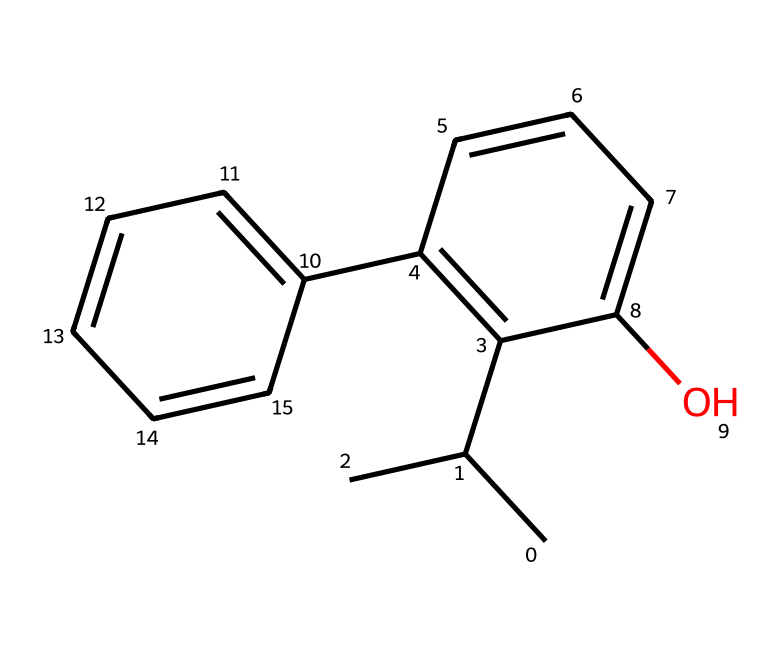What is the molecular formula of propofol? The molecular formula can be derived from the count of each type of atom present in the SMILES representation. In the given SMILES, there are 12 carbons (C), 18 hydrogens (H), and 1 oxygen (O), leading to the formula C12H18O.
Answer: C12H18O How many rings are present in the chemical structure of propofol? Analyzing the SMILES, there are two distinct cycles present: one is a six-membered cyclohexene ring and the other is a five-membered ring, which indicates that the structure contains two rings.
Answer: 2 What type of functional group is represented in propofol? The presence of -OH in the structure indicates that propofol contains a hydroxyl functional group, which is characteristic of alcohols. This is key to its biological activity.
Answer: hydroxyl What is the total number of double bonds in propofol? By examining the structure, you can identify that there are three double bonds in total: two within the cyclohexene ring and one in the allylic position in the structure.
Answer: 3 Which part of propofol contributes to its sedative properties? The presence of the lipophilic alkyl chain and the hydroxyl group makes propofol highly soluble in lipids, which enhances its sedative effects. The chemical design allows for easy crossing of the blood-brain barrier, which is integral for its anesthetic properties.
Answer: lipophilic alkyl chain How many carbon atoms are in the longest carbon chain of propofol? The longest continuous chain is analyzed by following the connected carbon atoms in the structure. In this case, there are 4 carbon atoms in the longest chain connected in series, forming the base of propofol.
Answer: 4 What is the significance of the aromatic rings in propofol? The aromatic rings contribute to the overall stability and the pharmacokinetic properties of propofol, providing a hydrophobic character that affects its ability to penetrate biological membranes, crucial for its anesthetic action.
Answer: stability and pharmacokinetics 